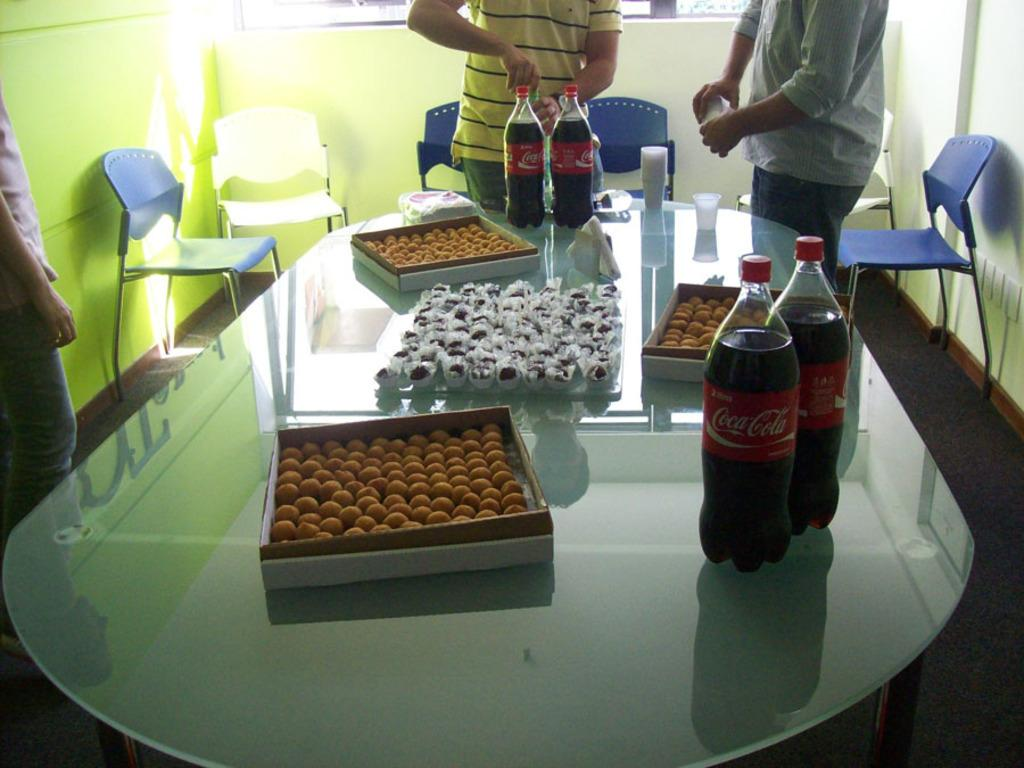What color is the wall that is visible in the image? The wall in the image is yellow. What can be seen on the wall in the image? There is a window visible on the wall in the image. How many people are standing in the image? There are three people standing in the image. What type of furniture is present in the image? There are chairs and tables in the image. What items can be seen on the table in the image? On the table, there is a bottle, glasses, and sweets. Where is the shelf located in the image? There is no shelf present in the image. What type of toothbrush is being used by the people in the image? There is no toothbrush visible in the image. 